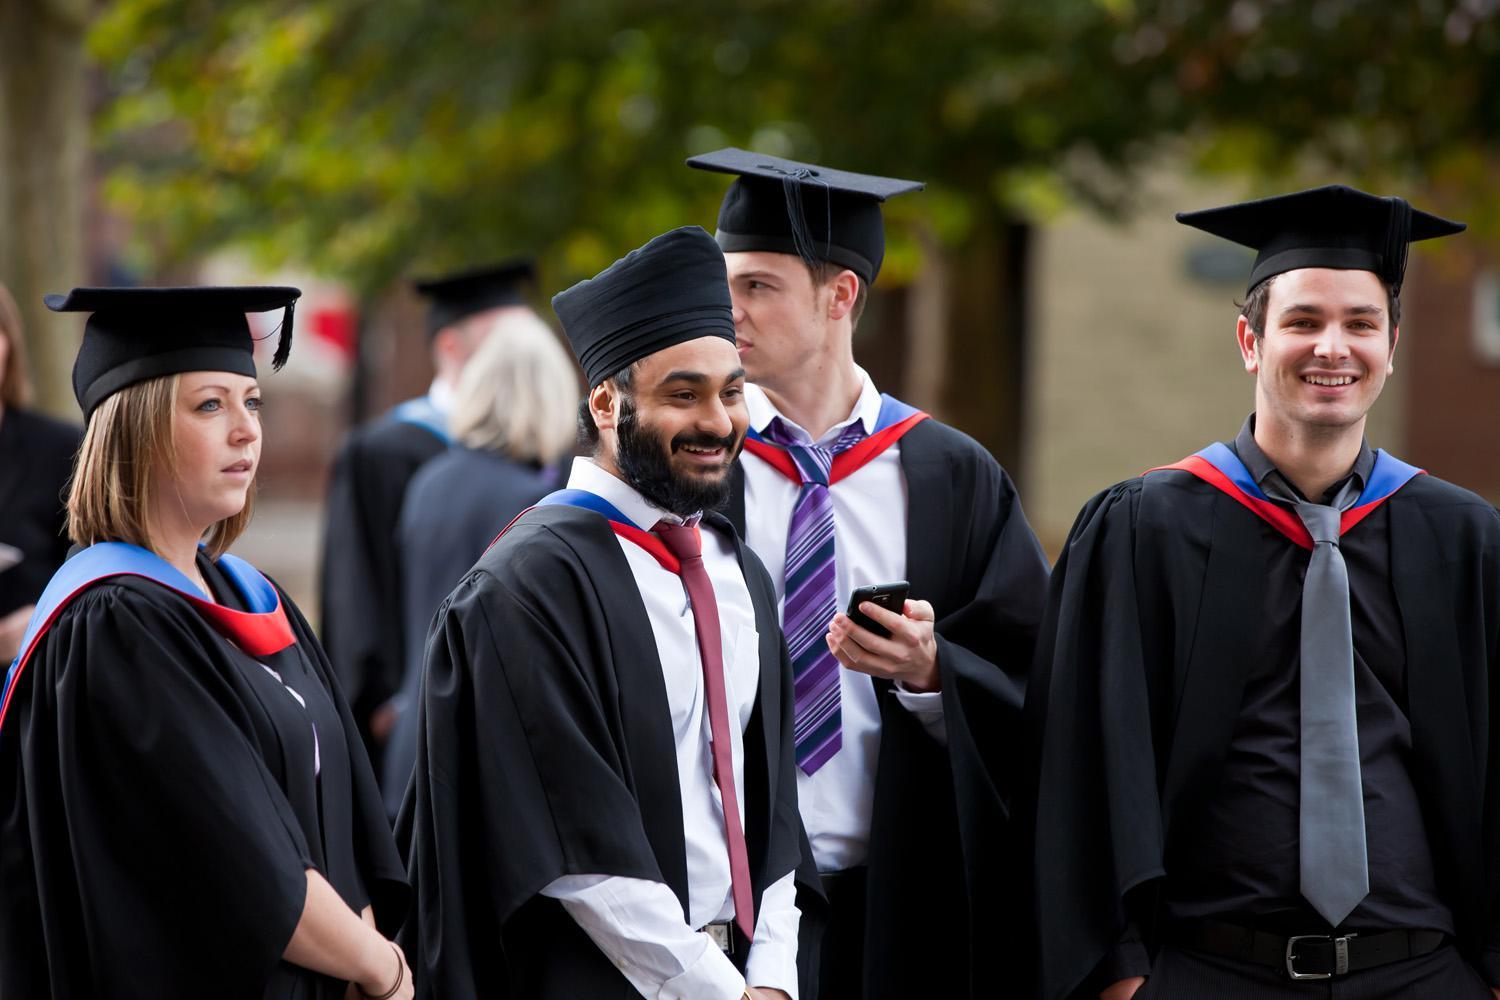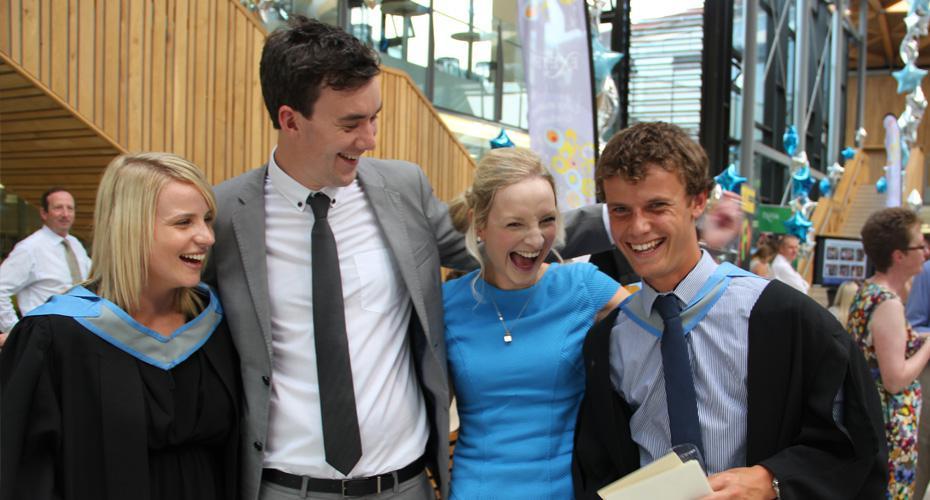The first image is the image on the left, the second image is the image on the right. Analyze the images presented: Is the assertion "Two graduates stand together outside posing for a picture in the image on the left." valid? Answer yes or no. No. The first image is the image on the left, the second image is the image on the right. Given the left and right images, does the statement "The right image shows multiple black-robed graduates wearing caps and  bright sky-blue sashes." hold true? Answer yes or no. No. 